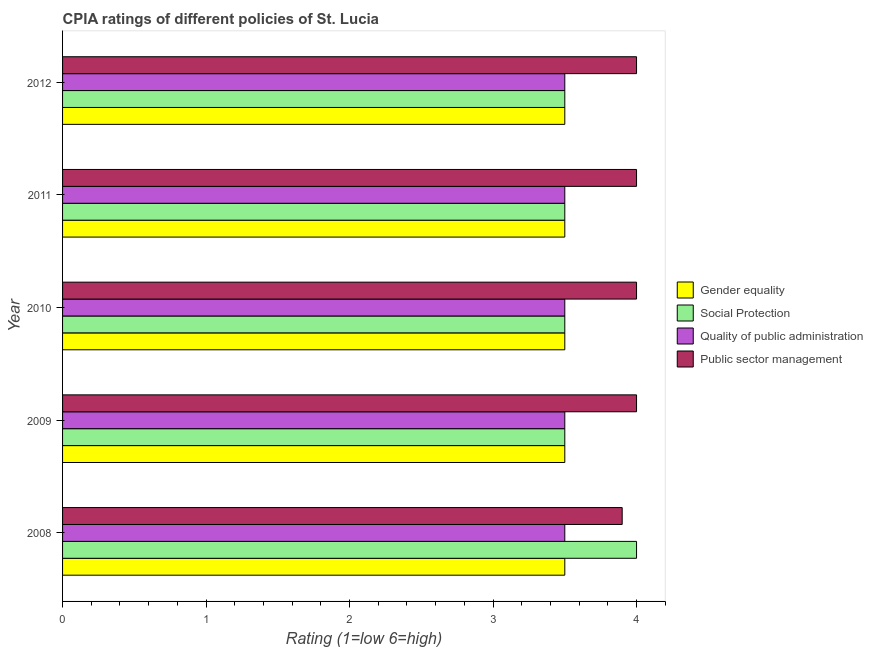What is the cpia rating of social protection in 2010?
Make the answer very short. 3.5. What is the total cpia rating of public sector management in the graph?
Provide a succinct answer. 19.9. What is the difference between the cpia rating of public sector management in 2008 and that in 2012?
Ensure brevity in your answer.  -0.1. What is the difference between the cpia rating of social protection in 2009 and the cpia rating of public sector management in 2011?
Give a very brief answer. -0.5. What is the ratio of the cpia rating of public sector management in 2008 to that in 2012?
Your answer should be compact. 0.97. Is the cpia rating of quality of public administration in 2010 less than that in 2012?
Your answer should be very brief. No. Is the difference between the cpia rating of social protection in 2009 and 2012 greater than the difference between the cpia rating of gender equality in 2009 and 2012?
Make the answer very short. No. What is the difference between the highest and the lowest cpia rating of public sector management?
Provide a short and direct response. 0.1. Is it the case that in every year, the sum of the cpia rating of social protection and cpia rating of quality of public administration is greater than the sum of cpia rating of gender equality and cpia rating of public sector management?
Provide a succinct answer. No. What does the 3rd bar from the top in 2010 represents?
Your answer should be compact. Social Protection. What does the 3rd bar from the bottom in 2011 represents?
Provide a short and direct response. Quality of public administration. Is it the case that in every year, the sum of the cpia rating of gender equality and cpia rating of social protection is greater than the cpia rating of quality of public administration?
Your answer should be very brief. Yes. How many bars are there?
Your response must be concise. 20. Are all the bars in the graph horizontal?
Make the answer very short. Yes. What is the difference between two consecutive major ticks on the X-axis?
Your answer should be compact. 1. Does the graph contain any zero values?
Give a very brief answer. No. How many legend labels are there?
Offer a terse response. 4. How are the legend labels stacked?
Keep it short and to the point. Vertical. What is the title of the graph?
Ensure brevity in your answer.  CPIA ratings of different policies of St. Lucia. What is the label or title of the X-axis?
Your answer should be very brief. Rating (1=low 6=high). What is the Rating (1=low 6=high) of Quality of public administration in 2008?
Keep it short and to the point. 3.5. What is the Rating (1=low 6=high) of Public sector management in 2008?
Offer a very short reply. 3.9. What is the Rating (1=low 6=high) of Gender equality in 2009?
Your answer should be very brief. 3.5. What is the Rating (1=low 6=high) in Quality of public administration in 2009?
Keep it short and to the point. 3.5. What is the Rating (1=low 6=high) in Public sector management in 2009?
Keep it short and to the point. 4. What is the Rating (1=low 6=high) of Gender equality in 2010?
Provide a succinct answer. 3.5. What is the Rating (1=low 6=high) in Quality of public administration in 2010?
Offer a terse response. 3.5. What is the Rating (1=low 6=high) in Social Protection in 2011?
Offer a terse response. 3.5. What is the Rating (1=low 6=high) in Quality of public administration in 2011?
Give a very brief answer. 3.5. What is the Rating (1=low 6=high) in Public sector management in 2011?
Your answer should be very brief. 4. What is the Rating (1=low 6=high) in Public sector management in 2012?
Your response must be concise. 4. Across all years, what is the maximum Rating (1=low 6=high) of Gender equality?
Your answer should be very brief. 3.5. Across all years, what is the maximum Rating (1=low 6=high) in Social Protection?
Keep it short and to the point. 4. Across all years, what is the maximum Rating (1=low 6=high) in Public sector management?
Give a very brief answer. 4. Across all years, what is the minimum Rating (1=low 6=high) in Quality of public administration?
Your response must be concise. 3.5. What is the difference between the Rating (1=low 6=high) in Gender equality in 2008 and that in 2009?
Your response must be concise. 0. What is the difference between the Rating (1=low 6=high) of Quality of public administration in 2008 and that in 2009?
Offer a terse response. 0. What is the difference between the Rating (1=low 6=high) in Gender equality in 2008 and that in 2011?
Provide a short and direct response. 0. What is the difference between the Rating (1=low 6=high) of Social Protection in 2008 and that in 2011?
Your answer should be compact. 0.5. What is the difference between the Rating (1=low 6=high) in Public sector management in 2008 and that in 2011?
Make the answer very short. -0.1. What is the difference between the Rating (1=low 6=high) of Gender equality in 2008 and that in 2012?
Your response must be concise. 0. What is the difference between the Rating (1=low 6=high) of Quality of public administration in 2008 and that in 2012?
Your answer should be compact. 0. What is the difference between the Rating (1=low 6=high) of Social Protection in 2009 and that in 2010?
Give a very brief answer. 0. What is the difference between the Rating (1=low 6=high) in Quality of public administration in 2009 and that in 2010?
Your answer should be very brief. 0. What is the difference between the Rating (1=low 6=high) in Public sector management in 2009 and that in 2010?
Provide a succinct answer. 0. What is the difference between the Rating (1=low 6=high) of Social Protection in 2009 and that in 2011?
Offer a terse response. 0. What is the difference between the Rating (1=low 6=high) in Quality of public administration in 2009 and that in 2011?
Provide a short and direct response. 0. What is the difference between the Rating (1=low 6=high) in Gender equality in 2009 and that in 2012?
Give a very brief answer. 0. What is the difference between the Rating (1=low 6=high) in Quality of public administration in 2009 and that in 2012?
Your answer should be compact. 0. What is the difference between the Rating (1=low 6=high) in Public sector management in 2009 and that in 2012?
Give a very brief answer. 0. What is the difference between the Rating (1=low 6=high) of Gender equality in 2010 and that in 2011?
Your answer should be very brief. 0. What is the difference between the Rating (1=low 6=high) of Public sector management in 2010 and that in 2011?
Offer a terse response. 0. What is the difference between the Rating (1=low 6=high) of Gender equality in 2010 and that in 2012?
Your answer should be very brief. 0. What is the difference between the Rating (1=low 6=high) in Quality of public administration in 2010 and that in 2012?
Give a very brief answer. 0. What is the difference between the Rating (1=low 6=high) of Public sector management in 2010 and that in 2012?
Keep it short and to the point. 0. What is the difference between the Rating (1=low 6=high) in Gender equality in 2011 and that in 2012?
Provide a succinct answer. 0. What is the difference between the Rating (1=low 6=high) of Public sector management in 2011 and that in 2012?
Give a very brief answer. 0. What is the difference between the Rating (1=low 6=high) of Social Protection in 2008 and the Rating (1=low 6=high) of Quality of public administration in 2009?
Your answer should be very brief. 0.5. What is the difference between the Rating (1=low 6=high) in Gender equality in 2008 and the Rating (1=low 6=high) in Social Protection in 2010?
Your response must be concise. 0. What is the difference between the Rating (1=low 6=high) of Gender equality in 2008 and the Rating (1=low 6=high) of Quality of public administration in 2010?
Your answer should be very brief. 0. What is the difference between the Rating (1=low 6=high) of Social Protection in 2008 and the Rating (1=low 6=high) of Quality of public administration in 2010?
Ensure brevity in your answer.  0.5. What is the difference between the Rating (1=low 6=high) in Social Protection in 2008 and the Rating (1=low 6=high) in Public sector management in 2010?
Your answer should be very brief. 0. What is the difference between the Rating (1=low 6=high) in Quality of public administration in 2008 and the Rating (1=low 6=high) in Public sector management in 2010?
Offer a terse response. -0.5. What is the difference between the Rating (1=low 6=high) of Gender equality in 2008 and the Rating (1=low 6=high) of Social Protection in 2011?
Your answer should be very brief. 0. What is the difference between the Rating (1=low 6=high) of Gender equality in 2008 and the Rating (1=low 6=high) of Quality of public administration in 2011?
Make the answer very short. 0. What is the difference between the Rating (1=low 6=high) in Gender equality in 2008 and the Rating (1=low 6=high) in Public sector management in 2011?
Offer a terse response. -0.5. What is the difference between the Rating (1=low 6=high) in Social Protection in 2008 and the Rating (1=low 6=high) in Public sector management in 2011?
Ensure brevity in your answer.  0. What is the difference between the Rating (1=low 6=high) in Quality of public administration in 2008 and the Rating (1=low 6=high) in Public sector management in 2011?
Your answer should be compact. -0.5. What is the difference between the Rating (1=low 6=high) of Gender equality in 2008 and the Rating (1=low 6=high) of Quality of public administration in 2012?
Your answer should be compact. 0. What is the difference between the Rating (1=low 6=high) in Gender equality in 2008 and the Rating (1=low 6=high) in Public sector management in 2012?
Make the answer very short. -0.5. What is the difference between the Rating (1=low 6=high) of Social Protection in 2008 and the Rating (1=low 6=high) of Quality of public administration in 2012?
Provide a succinct answer. 0.5. What is the difference between the Rating (1=low 6=high) of Social Protection in 2008 and the Rating (1=low 6=high) of Public sector management in 2012?
Provide a short and direct response. 0. What is the difference between the Rating (1=low 6=high) in Quality of public administration in 2008 and the Rating (1=low 6=high) in Public sector management in 2012?
Your answer should be very brief. -0.5. What is the difference between the Rating (1=low 6=high) of Social Protection in 2009 and the Rating (1=low 6=high) of Quality of public administration in 2010?
Your answer should be compact. 0. What is the difference between the Rating (1=low 6=high) of Quality of public administration in 2009 and the Rating (1=low 6=high) of Public sector management in 2010?
Ensure brevity in your answer.  -0.5. What is the difference between the Rating (1=low 6=high) of Gender equality in 2009 and the Rating (1=low 6=high) of Quality of public administration in 2011?
Your answer should be very brief. 0. What is the difference between the Rating (1=low 6=high) of Quality of public administration in 2009 and the Rating (1=low 6=high) of Public sector management in 2011?
Your answer should be very brief. -0.5. What is the difference between the Rating (1=low 6=high) of Gender equality in 2009 and the Rating (1=low 6=high) of Social Protection in 2012?
Your response must be concise. 0. What is the difference between the Rating (1=low 6=high) of Social Protection in 2009 and the Rating (1=low 6=high) of Public sector management in 2012?
Your answer should be very brief. -0.5. What is the difference between the Rating (1=low 6=high) in Quality of public administration in 2009 and the Rating (1=low 6=high) in Public sector management in 2012?
Provide a short and direct response. -0.5. What is the difference between the Rating (1=low 6=high) in Gender equality in 2010 and the Rating (1=low 6=high) in Social Protection in 2011?
Offer a terse response. 0. What is the difference between the Rating (1=low 6=high) in Gender equality in 2010 and the Rating (1=low 6=high) in Quality of public administration in 2011?
Provide a short and direct response. 0. What is the difference between the Rating (1=low 6=high) in Social Protection in 2010 and the Rating (1=low 6=high) in Quality of public administration in 2011?
Your response must be concise. 0. What is the difference between the Rating (1=low 6=high) of Quality of public administration in 2010 and the Rating (1=low 6=high) of Public sector management in 2011?
Your answer should be compact. -0.5. What is the difference between the Rating (1=low 6=high) in Gender equality in 2010 and the Rating (1=low 6=high) in Social Protection in 2012?
Your answer should be very brief. 0. What is the difference between the Rating (1=low 6=high) in Gender equality in 2010 and the Rating (1=low 6=high) in Quality of public administration in 2012?
Ensure brevity in your answer.  0. What is the difference between the Rating (1=low 6=high) of Quality of public administration in 2010 and the Rating (1=low 6=high) of Public sector management in 2012?
Your answer should be compact. -0.5. What is the difference between the Rating (1=low 6=high) in Gender equality in 2011 and the Rating (1=low 6=high) in Social Protection in 2012?
Provide a short and direct response. 0. What is the difference between the Rating (1=low 6=high) in Gender equality in 2011 and the Rating (1=low 6=high) in Public sector management in 2012?
Make the answer very short. -0.5. What is the difference between the Rating (1=low 6=high) in Social Protection in 2011 and the Rating (1=low 6=high) in Public sector management in 2012?
Your response must be concise. -0.5. What is the average Rating (1=low 6=high) of Gender equality per year?
Provide a short and direct response. 3.5. What is the average Rating (1=low 6=high) of Social Protection per year?
Provide a short and direct response. 3.6. What is the average Rating (1=low 6=high) of Public sector management per year?
Give a very brief answer. 3.98. In the year 2009, what is the difference between the Rating (1=low 6=high) of Gender equality and Rating (1=low 6=high) of Social Protection?
Provide a short and direct response. 0. In the year 2009, what is the difference between the Rating (1=low 6=high) in Gender equality and Rating (1=low 6=high) in Quality of public administration?
Provide a succinct answer. 0. In the year 2009, what is the difference between the Rating (1=low 6=high) in Social Protection and Rating (1=low 6=high) in Quality of public administration?
Offer a very short reply. 0. In the year 2009, what is the difference between the Rating (1=low 6=high) in Social Protection and Rating (1=low 6=high) in Public sector management?
Provide a short and direct response. -0.5. In the year 2010, what is the difference between the Rating (1=low 6=high) in Gender equality and Rating (1=low 6=high) in Social Protection?
Your answer should be compact. 0. In the year 2010, what is the difference between the Rating (1=low 6=high) in Gender equality and Rating (1=low 6=high) in Public sector management?
Offer a terse response. -0.5. In the year 2010, what is the difference between the Rating (1=low 6=high) in Social Protection and Rating (1=low 6=high) in Public sector management?
Your response must be concise. -0.5. In the year 2010, what is the difference between the Rating (1=low 6=high) of Quality of public administration and Rating (1=low 6=high) of Public sector management?
Provide a short and direct response. -0.5. In the year 2011, what is the difference between the Rating (1=low 6=high) of Quality of public administration and Rating (1=low 6=high) of Public sector management?
Your answer should be very brief. -0.5. In the year 2012, what is the difference between the Rating (1=low 6=high) in Gender equality and Rating (1=low 6=high) in Social Protection?
Provide a succinct answer. 0. In the year 2012, what is the difference between the Rating (1=low 6=high) in Social Protection and Rating (1=low 6=high) in Quality of public administration?
Keep it short and to the point. 0. What is the ratio of the Rating (1=low 6=high) of Gender equality in 2008 to that in 2009?
Give a very brief answer. 1. What is the ratio of the Rating (1=low 6=high) in Social Protection in 2008 to that in 2009?
Provide a short and direct response. 1.14. What is the ratio of the Rating (1=low 6=high) in Quality of public administration in 2008 to that in 2009?
Your answer should be very brief. 1. What is the ratio of the Rating (1=low 6=high) of Social Protection in 2008 to that in 2010?
Ensure brevity in your answer.  1.14. What is the ratio of the Rating (1=low 6=high) in Public sector management in 2008 to that in 2012?
Make the answer very short. 0.97. What is the ratio of the Rating (1=low 6=high) in Public sector management in 2009 to that in 2011?
Make the answer very short. 1. What is the ratio of the Rating (1=low 6=high) of Gender equality in 2009 to that in 2012?
Offer a very short reply. 1. What is the ratio of the Rating (1=low 6=high) of Social Protection in 2009 to that in 2012?
Offer a very short reply. 1. What is the ratio of the Rating (1=low 6=high) in Quality of public administration in 2009 to that in 2012?
Offer a terse response. 1. What is the ratio of the Rating (1=low 6=high) of Public sector management in 2009 to that in 2012?
Offer a terse response. 1. What is the ratio of the Rating (1=low 6=high) of Gender equality in 2010 to that in 2011?
Provide a short and direct response. 1. What is the ratio of the Rating (1=low 6=high) of Quality of public administration in 2010 to that in 2011?
Give a very brief answer. 1. What is the ratio of the Rating (1=low 6=high) of Public sector management in 2010 to that in 2011?
Provide a short and direct response. 1. What is the ratio of the Rating (1=low 6=high) of Quality of public administration in 2010 to that in 2012?
Keep it short and to the point. 1. What is the ratio of the Rating (1=low 6=high) of Public sector management in 2010 to that in 2012?
Make the answer very short. 1. What is the ratio of the Rating (1=low 6=high) in Gender equality in 2011 to that in 2012?
Keep it short and to the point. 1. What is the ratio of the Rating (1=low 6=high) of Social Protection in 2011 to that in 2012?
Your response must be concise. 1. What is the ratio of the Rating (1=low 6=high) of Public sector management in 2011 to that in 2012?
Make the answer very short. 1. What is the difference between the highest and the second highest Rating (1=low 6=high) in Social Protection?
Offer a terse response. 0.5. What is the difference between the highest and the second highest Rating (1=low 6=high) of Quality of public administration?
Your response must be concise. 0. What is the difference between the highest and the lowest Rating (1=low 6=high) in Social Protection?
Make the answer very short. 0.5. What is the difference between the highest and the lowest Rating (1=low 6=high) in Quality of public administration?
Ensure brevity in your answer.  0. What is the difference between the highest and the lowest Rating (1=low 6=high) of Public sector management?
Give a very brief answer. 0.1. 